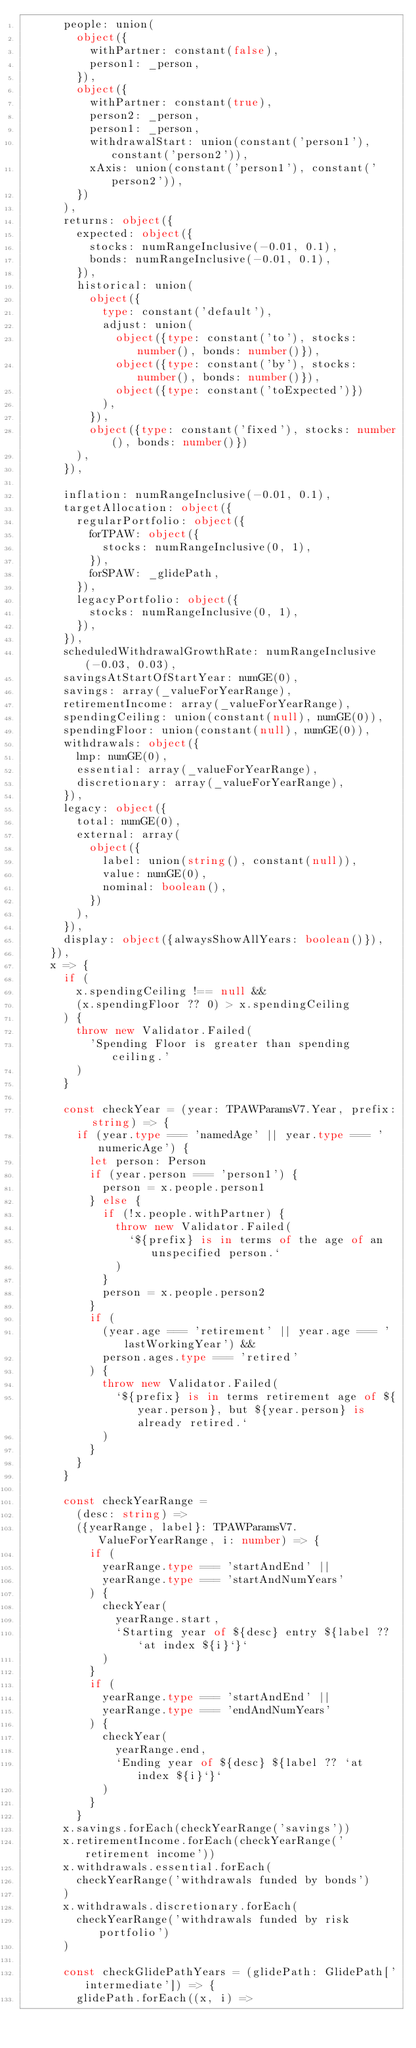Convert code to text. <code><loc_0><loc_0><loc_500><loc_500><_TypeScript_>      people: union(
        object({
          withPartner: constant(false),
          person1: _person,
        }),
        object({
          withPartner: constant(true),
          person2: _person,
          person1: _person,
          withdrawalStart: union(constant('person1'), constant('person2')),
          xAxis: union(constant('person1'), constant('person2')),
        })
      ),
      returns: object({
        expected: object({
          stocks: numRangeInclusive(-0.01, 0.1),
          bonds: numRangeInclusive(-0.01, 0.1),
        }),
        historical: union(
          object({
            type: constant('default'),
            adjust: union(
              object({type: constant('to'), stocks: number(), bonds: number()}),
              object({type: constant('by'), stocks: number(), bonds: number()}),
              object({type: constant('toExpected')})
            ),
          }),
          object({type: constant('fixed'), stocks: number(), bonds: number()})
        ),
      }),

      inflation: numRangeInclusive(-0.01, 0.1),
      targetAllocation: object({
        regularPortfolio: object({
          forTPAW: object({
            stocks: numRangeInclusive(0, 1),
          }),
          forSPAW: _glidePath,
        }),
        legacyPortfolio: object({
          stocks: numRangeInclusive(0, 1),
        }),
      }),
      scheduledWithdrawalGrowthRate: numRangeInclusive(-0.03, 0.03),
      savingsAtStartOfStartYear: numGE(0),
      savings: array(_valueForYearRange),
      retirementIncome: array(_valueForYearRange),
      spendingCeiling: union(constant(null), numGE(0)),
      spendingFloor: union(constant(null), numGE(0)),
      withdrawals: object({
        lmp: numGE(0),
        essential: array(_valueForYearRange),
        discretionary: array(_valueForYearRange),
      }),
      legacy: object({
        total: numGE(0),
        external: array(
          object({
            label: union(string(), constant(null)),
            value: numGE(0),
            nominal: boolean(),
          })
        ),
      }),
      display: object({alwaysShowAllYears: boolean()}),
    }),
    x => {
      if (
        x.spendingCeiling !== null &&
        (x.spendingFloor ?? 0) > x.spendingCeiling
      ) {
        throw new Validator.Failed(
          'Spending Floor is greater than spending ceiling.'
        )
      }

      const checkYear = (year: TPAWParamsV7.Year, prefix: string) => {
        if (year.type === 'namedAge' || year.type === 'numericAge') {
          let person: Person
          if (year.person === 'person1') {
            person = x.people.person1
          } else {
            if (!x.people.withPartner) {
              throw new Validator.Failed(
                `${prefix} is in terms of the age of an unspecified person.`
              )
            }
            person = x.people.person2
          }
          if (
            (year.age === 'retirement' || year.age === 'lastWorkingYear') &&
            person.ages.type === 'retired'
          ) {
            throw new Validator.Failed(
              `${prefix} is in terms retirement age of ${year.person}, but ${year.person} is already retired.`
            )
          }
        }
      }

      const checkYearRange =
        (desc: string) =>
        ({yearRange, label}: TPAWParamsV7.ValueForYearRange, i: number) => {
          if (
            yearRange.type === 'startAndEnd' ||
            yearRange.type === 'startAndNumYears'
          ) {
            checkYear(
              yearRange.start,
              `Starting year of ${desc} entry ${label ?? `at index ${i}`}`
            )
          }
          if (
            yearRange.type === 'startAndEnd' ||
            yearRange.type === 'endAndNumYears'
          ) {
            checkYear(
              yearRange.end,
              `Ending year of ${desc} ${label ?? `at index ${i}`}`
            )
          }
        }
      x.savings.forEach(checkYearRange('savings'))
      x.retirementIncome.forEach(checkYearRange('retirement income'))
      x.withdrawals.essential.forEach(
        checkYearRange('withdrawals funded by bonds')
      )
      x.withdrawals.discretionary.forEach(
        checkYearRange('withdrawals funded by risk portfolio')
      )

      const checkGlidePathYears = (glidePath: GlidePath['intermediate']) => {
        glidePath.forEach((x, i) =></code> 